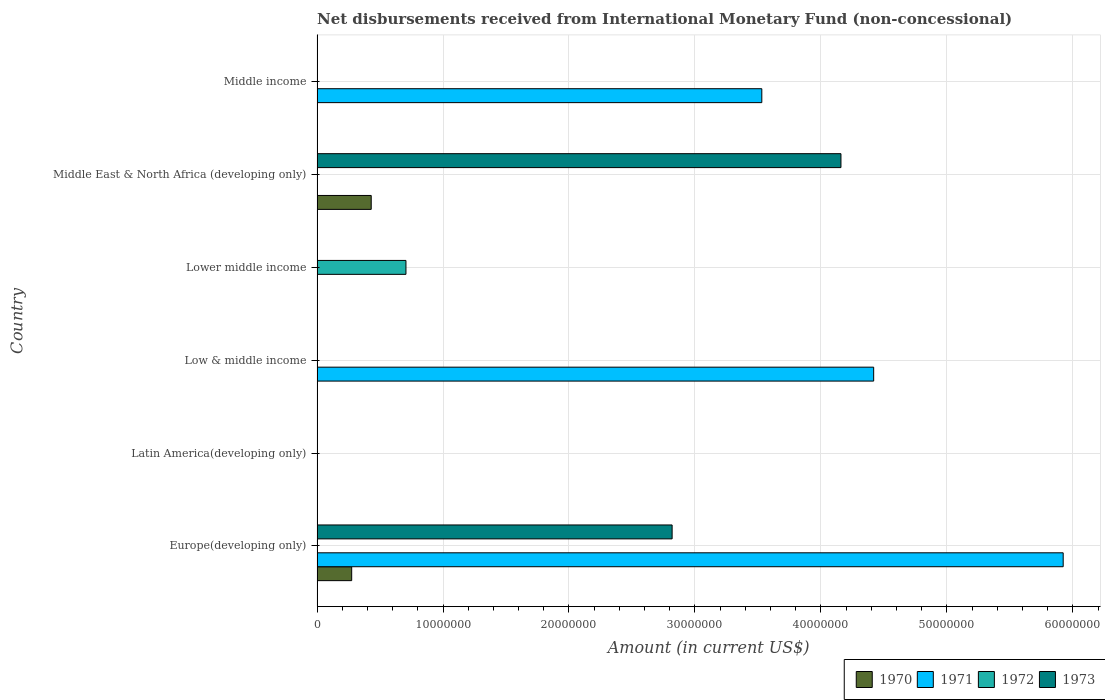Are the number of bars on each tick of the Y-axis equal?
Ensure brevity in your answer.  No. What is the label of the 6th group of bars from the top?
Offer a very short reply. Europe(developing only). In how many cases, is the number of bars for a given country not equal to the number of legend labels?
Your answer should be compact. 6. Across all countries, what is the maximum amount of disbursements received from International Monetary Fund in 1973?
Provide a short and direct response. 4.16e+07. In which country was the amount of disbursements received from International Monetary Fund in 1970 maximum?
Your answer should be very brief. Middle East & North Africa (developing only). What is the total amount of disbursements received from International Monetary Fund in 1972 in the graph?
Ensure brevity in your answer.  7.06e+06. What is the difference between the amount of disbursements received from International Monetary Fund in 1971 in Low & middle income and that in Middle income?
Your response must be concise. 8.88e+06. What is the average amount of disbursements received from International Monetary Fund in 1971 per country?
Your answer should be compact. 2.31e+07. What is the difference between the amount of disbursements received from International Monetary Fund in 1973 and amount of disbursements received from International Monetary Fund in 1970 in Middle East & North Africa (developing only)?
Keep it short and to the point. 3.73e+07. In how many countries, is the amount of disbursements received from International Monetary Fund in 1972 greater than 28000000 US$?
Your answer should be very brief. 0. Is the amount of disbursements received from International Monetary Fund in 1971 in Low & middle income less than that in Middle income?
Keep it short and to the point. No. What is the difference between the highest and the second highest amount of disbursements received from International Monetary Fund in 1971?
Keep it short and to the point. 1.50e+07. What is the difference between the highest and the lowest amount of disbursements received from International Monetary Fund in 1973?
Your response must be concise. 4.16e+07. What is the difference between two consecutive major ticks on the X-axis?
Provide a succinct answer. 1.00e+07. Are the values on the major ticks of X-axis written in scientific E-notation?
Keep it short and to the point. No. Does the graph contain grids?
Keep it short and to the point. Yes. Where does the legend appear in the graph?
Your response must be concise. Bottom right. How are the legend labels stacked?
Offer a very short reply. Horizontal. What is the title of the graph?
Your answer should be very brief. Net disbursements received from International Monetary Fund (non-concessional). What is the label or title of the X-axis?
Your answer should be compact. Amount (in current US$). What is the label or title of the Y-axis?
Your answer should be compact. Country. What is the Amount (in current US$) in 1970 in Europe(developing only)?
Keep it short and to the point. 2.75e+06. What is the Amount (in current US$) in 1971 in Europe(developing only)?
Provide a short and direct response. 5.92e+07. What is the Amount (in current US$) of 1972 in Europe(developing only)?
Offer a very short reply. 0. What is the Amount (in current US$) in 1973 in Europe(developing only)?
Provide a succinct answer. 2.82e+07. What is the Amount (in current US$) in 1970 in Latin America(developing only)?
Offer a terse response. 0. What is the Amount (in current US$) in 1971 in Latin America(developing only)?
Ensure brevity in your answer.  0. What is the Amount (in current US$) in 1972 in Latin America(developing only)?
Ensure brevity in your answer.  0. What is the Amount (in current US$) of 1973 in Latin America(developing only)?
Make the answer very short. 0. What is the Amount (in current US$) of 1970 in Low & middle income?
Provide a succinct answer. 0. What is the Amount (in current US$) of 1971 in Low & middle income?
Provide a short and direct response. 4.42e+07. What is the Amount (in current US$) in 1973 in Low & middle income?
Your answer should be very brief. 0. What is the Amount (in current US$) of 1970 in Lower middle income?
Ensure brevity in your answer.  0. What is the Amount (in current US$) in 1972 in Lower middle income?
Make the answer very short. 7.06e+06. What is the Amount (in current US$) in 1970 in Middle East & North Africa (developing only)?
Ensure brevity in your answer.  4.30e+06. What is the Amount (in current US$) of 1972 in Middle East & North Africa (developing only)?
Ensure brevity in your answer.  0. What is the Amount (in current US$) in 1973 in Middle East & North Africa (developing only)?
Your response must be concise. 4.16e+07. What is the Amount (in current US$) of 1970 in Middle income?
Provide a short and direct response. 0. What is the Amount (in current US$) in 1971 in Middle income?
Provide a short and direct response. 3.53e+07. What is the Amount (in current US$) in 1972 in Middle income?
Your answer should be very brief. 0. Across all countries, what is the maximum Amount (in current US$) in 1970?
Offer a very short reply. 4.30e+06. Across all countries, what is the maximum Amount (in current US$) of 1971?
Provide a succinct answer. 5.92e+07. Across all countries, what is the maximum Amount (in current US$) of 1972?
Provide a short and direct response. 7.06e+06. Across all countries, what is the maximum Amount (in current US$) of 1973?
Keep it short and to the point. 4.16e+07. Across all countries, what is the minimum Amount (in current US$) of 1971?
Keep it short and to the point. 0. What is the total Amount (in current US$) in 1970 in the graph?
Your answer should be very brief. 7.05e+06. What is the total Amount (in current US$) in 1971 in the graph?
Your answer should be compact. 1.39e+08. What is the total Amount (in current US$) of 1972 in the graph?
Provide a succinct answer. 7.06e+06. What is the total Amount (in current US$) in 1973 in the graph?
Your response must be concise. 6.98e+07. What is the difference between the Amount (in current US$) in 1971 in Europe(developing only) and that in Low & middle income?
Give a very brief answer. 1.50e+07. What is the difference between the Amount (in current US$) of 1970 in Europe(developing only) and that in Middle East & North Africa (developing only)?
Keep it short and to the point. -1.55e+06. What is the difference between the Amount (in current US$) of 1973 in Europe(developing only) and that in Middle East & North Africa (developing only)?
Your answer should be compact. -1.34e+07. What is the difference between the Amount (in current US$) in 1971 in Europe(developing only) and that in Middle income?
Offer a terse response. 2.39e+07. What is the difference between the Amount (in current US$) of 1971 in Low & middle income and that in Middle income?
Your answer should be very brief. 8.88e+06. What is the difference between the Amount (in current US$) of 1970 in Europe(developing only) and the Amount (in current US$) of 1971 in Low & middle income?
Offer a terse response. -4.14e+07. What is the difference between the Amount (in current US$) of 1970 in Europe(developing only) and the Amount (in current US$) of 1972 in Lower middle income?
Provide a short and direct response. -4.31e+06. What is the difference between the Amount (in current US$) of 1971 in Europe(developing only) and the Amount (in current US$) of 1972 in Lower middle income?
Your answer should be very brief. 5.22e+07. What is the difference between the Amount (in current US$) in 1970 in Europe(developing only) and the Amount (in current US$) in 1973 in Middle East & North Africa (developing only)?
Your answer should be compact. -3.88e+07. What is the difference between the Amount (in current US$) in 1971 in Europe(developing only) and the Amount (in current US$) in 1973 in Middle East & North Africa (developing only)?
Your answer should be compact. 1.76e+07. What is the difference between the Amount (in current US$) in 1970 in Europe(developing only) and the Amount (in current US$) in 1971 in Middle income?
Keep it short and to the point. -3.26e+07. What is the difference between the Amount (in current US$) in 1971 in Low & middle income and the Amount (in current US$) in 1972 in Lower middle income?
Give a very brief answer. 3.71e+07. What is the difference between the Amount (in current US$) in 1971 in Low & middle income and the Amount (in current US$) in 1973 in Middle East & North Africa (developing only)?
Provide a succinct answer. 2.60e+06. What is the difference between the Amount (in current US$) of 1972 in Lower middle income and the Amount (in current US$) of 1973 in Middle East & North Africa (developing only)?
Offer a very short reply. -3.45e+07. What is the difference between the Amount (in current US$) in 1970 in Middle East & North Africa (developing only) and the Amount (in current US$) in 1971 in Middle income?
Your response must be concise. -3.10e+07. What is the average Amount (in current US$) of 1970 per country?
Give a very brief answer. 1.18e+06. What is the average Amount (in current US$) of 1971 per country?
Make the answer very short. 2.31e+07. What is the average Amount (in current US$) of 1972 per country?
Offer a terse response. 1.18e+06. What is the average Amount (in current US$) in 1973 per country?
Offer a terse response. 1.16e+07. What is the difference between the Amount (in current US$) in 1970 and Amount (in current US$) in 1971 in Europe(developing only)?
Your answer should be very brief. -5.65e+07. What is the difference between the Amount (in current US$) of 1970 and Amount (in current US$) of 1973 in Europe(developing only)?
Keep it short and to the point. -2.54e+07. What is the difference between the Amount (in current US$) of 1971 and Amount (in current US$) of 1973 in Europe(developing only)?
Give a very brief answer. 3.10e+07. What is the difference between the Amount (in current US$) of 1970 and Amount (in current US$) of 1973 in Middle East & North Africa (developing only)?
Make the answer very short. -3.73e+07. What is the ratio of the Amount (in current US$) of 1971 in Europe(developing only) to that in Low & middle income?
Make the answer very short. 1.34. What is the ratio of the Amount (in current US$) in 1970 in Europe(developing only) to that in Middle East & North Africa (developing only)?
Provide a short and direct response. 0.64. What is the ratio of the Amount (in current US$) in 1973 in Europe(developing only) to that in Middle East & North Africa (developing only)?
Offer a terse response. 0.68. What is the ratio of the Amount (in current US$) in 1971 in Europe(developing only) to that in Middle income?
Your answer should be very brief. 1.68. What is the ratio of the Amount (in current US$) of 1971 in Low & middle income to that in Middle income?
Make the answer very short. 1.25. What is the difference between the highest and the second highest Amount (in current US$) in 1971?
Offer a terse response. 1.50e+07. What is the difference between the highest and the lowest Amount (in current US$) of 1970?
Your response must be concise. 4.30e+06. What is the difference between the highest and the lowest Amount (in current US$) of 1971?
Make the answer very short. 5.92e+07. What is the difference between the highest and the lowest Amount (in current US$) of 1972?
Your answer should be compact. 7.06e+06. What is the difference between the highest and the lowest Amount (in current US$) of 1973?
Your response must be concise. 4.16e+07. 